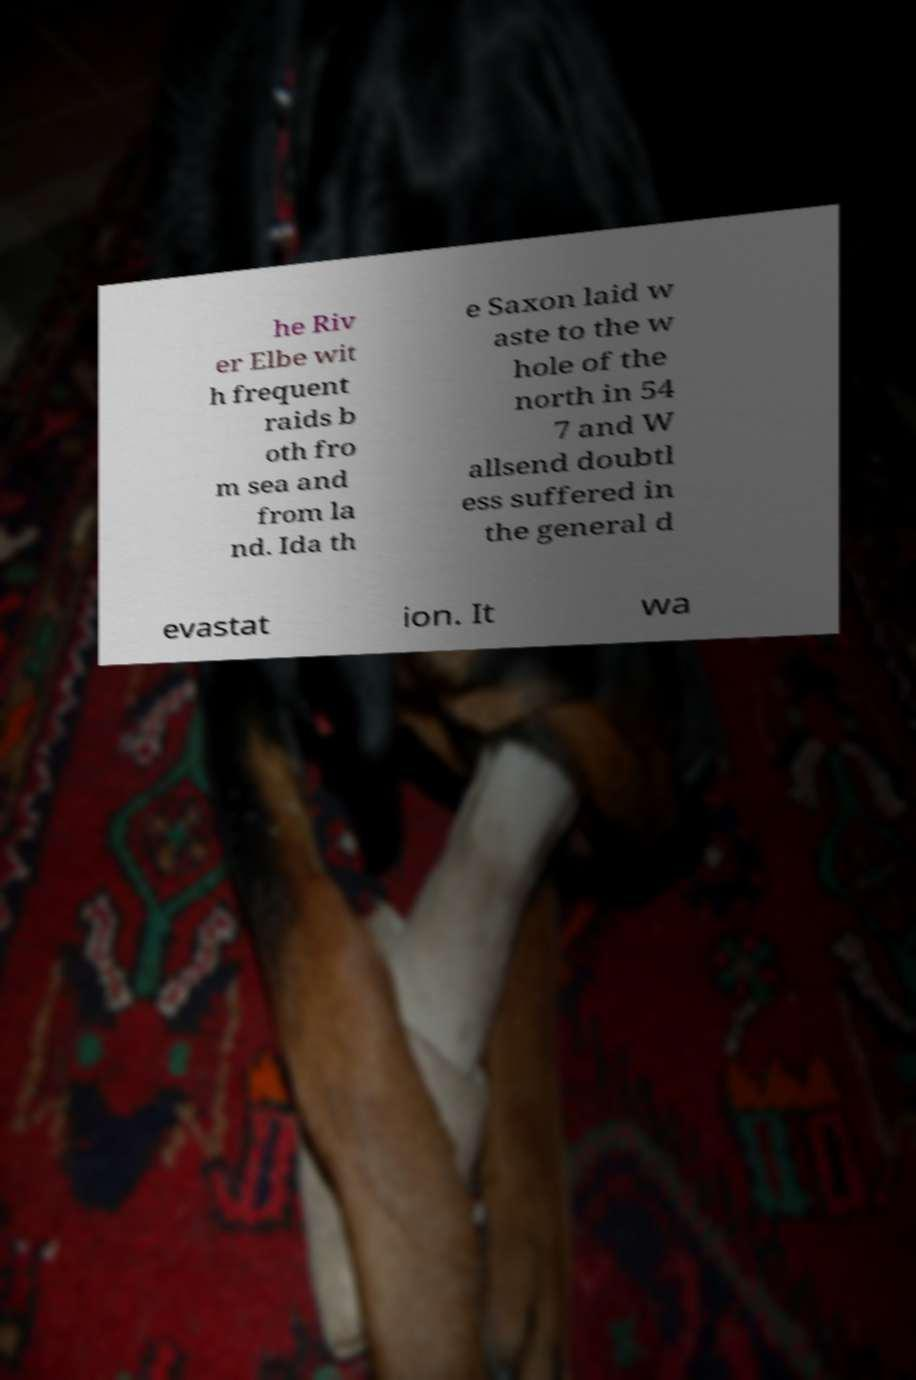Could you extract and type out the text from this image? he Riv er Elbe wit h frequent raids b oth fro m sea and from la nd. Ida th e Saxon laid w aste to the w hole of the north in 54 7 and W allsend doubtl ess suffered in the general d evastat ion. It wa 